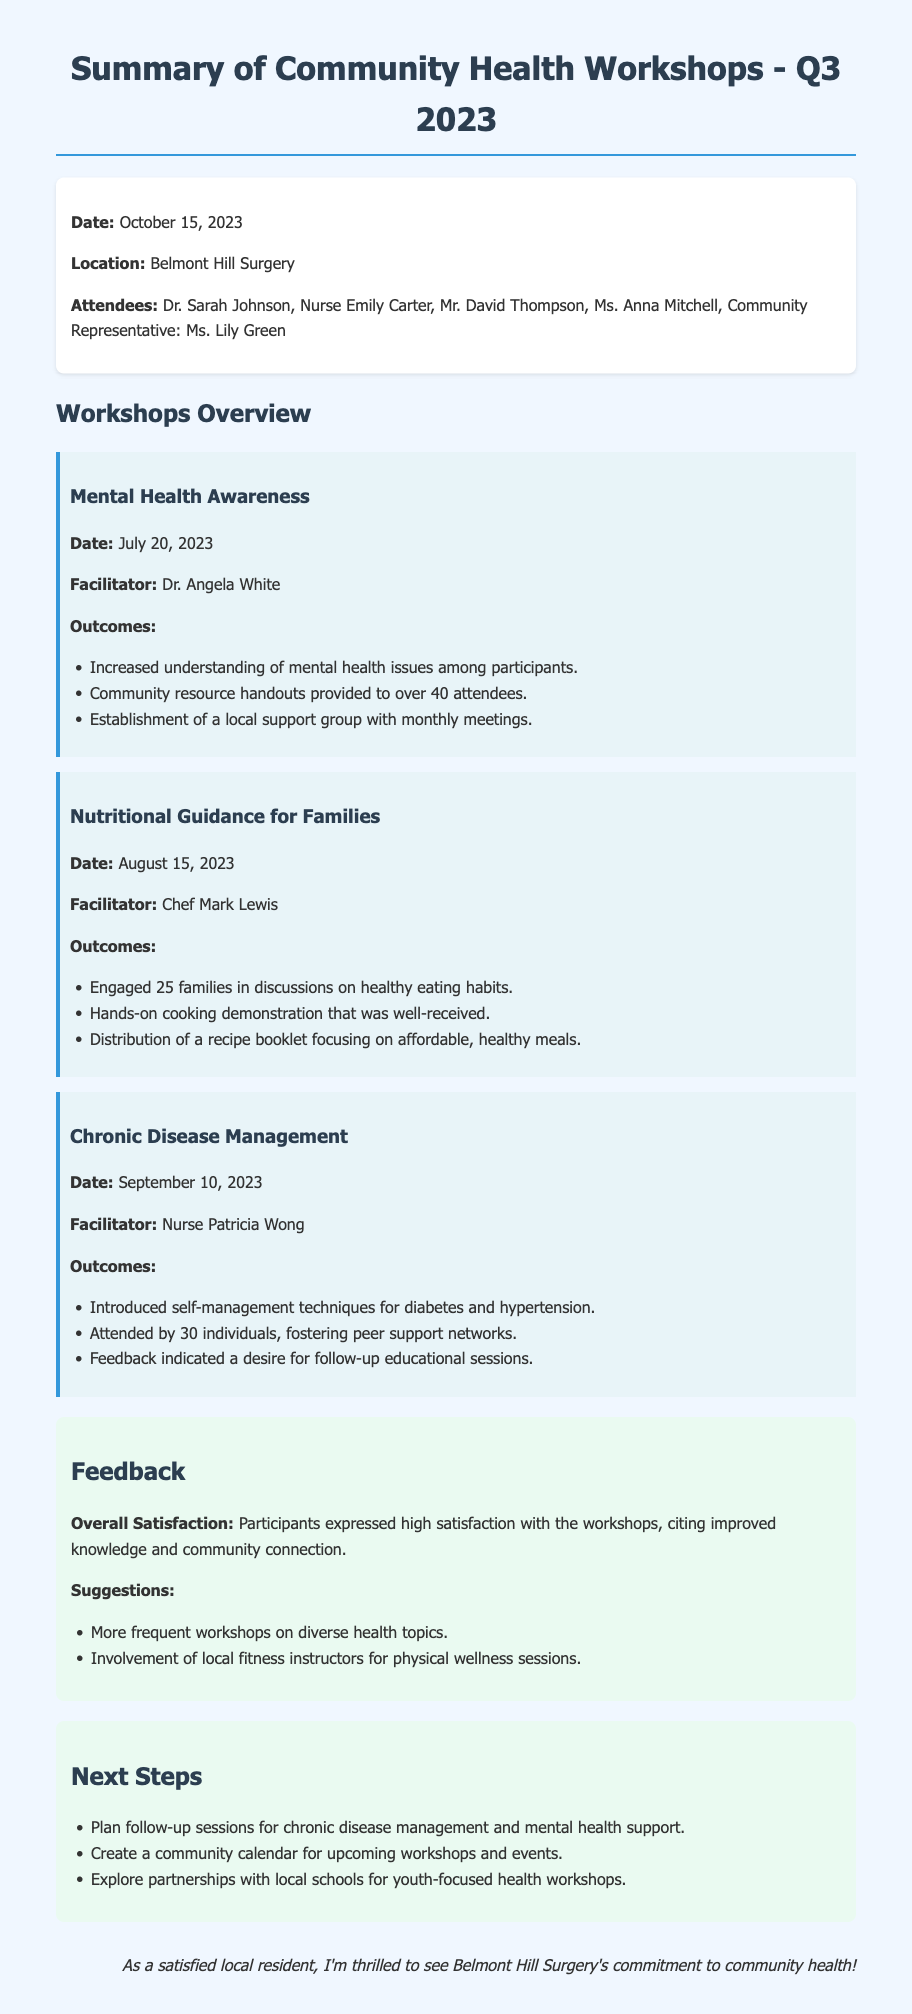What was the date of the workshops summary? The date of the workshops summary is explicitly stated at the beginning of the document.
Answer: October 15, 2023 Who facilitated the Nutritional Guidance for Families workshop? The document mentions the facilitator of each workshop under the respective workshop details.
Answer: Chef Mark Lewis How many families were engaged in the Nutritional Guidance workshop? The number of families engaged is a specific outcome listed in the workshop section.
Answer: 25 families What was a noted outcome of the Chronic Disease Management workshop? This information can be found in the outcomes listed for the workshop, detailing what participants gained.
Answer: Self-management techniques for diabetes and hypertension What overall feedback did participants express about the workshops? The overall satisfaction is summarized in the feedback section, highlighting participants' feelings.
Answer: High satisfaction What suggestions were made for future workshops? Suggestions from participants are collected in the feedback section as part of the document's summary.
Answer: More frequent workshops on diverse health topics What is one of the next steps outlined in the document? Next steps are listed at the end of the document, indicating future actions planned.
Answer: Plan follow-up sessions for chronic disease management and mental health support How many individuals attended the Chronic Disease Management workshop? This information is specified in the outcomes for that workshop in the document.
Answer: 30 individuals 